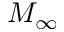Convert formula to latex. <formula><loc_0><loc_0><loc_500><loc_500>M _ { \infty }</formula> 